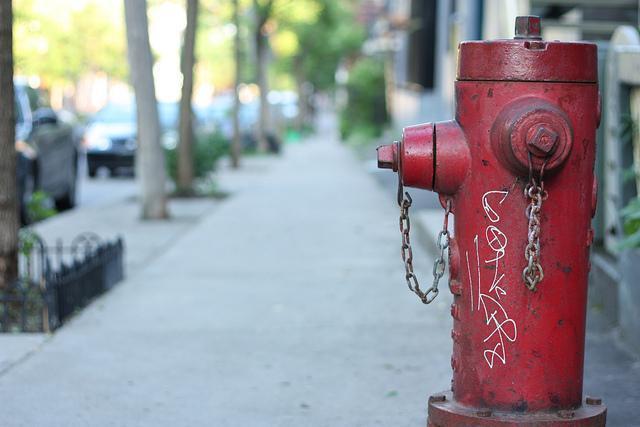How many cars are there?
Give a very brief answer. 3. How many people are shown?
Give a very brief answer. 0. 